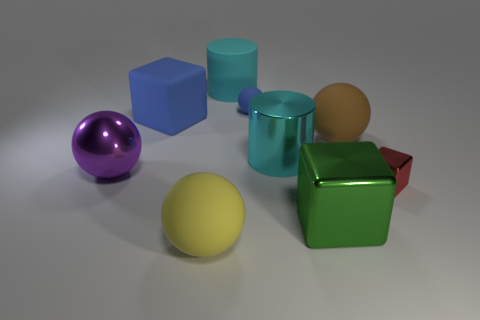Subtract all purple spheres. How many spheres are left? 3 Subtract all green balls. Subtract all red blocks. How many balls are left? 4 Add 1 big cyan things. How many objects exist? 10 Subtract all blocks. How many objects are left? 6 Subtract all small blue balls. Subtract all big blue matte objects. How many objects are left? 7 Add 5 large yellow objects. How many large yellow objects are left? 6 Add 4 big brown rubber balls. How many big brown rubber balls exist? 5 Subtract 0 green cylinders. How many objects are left? 9 